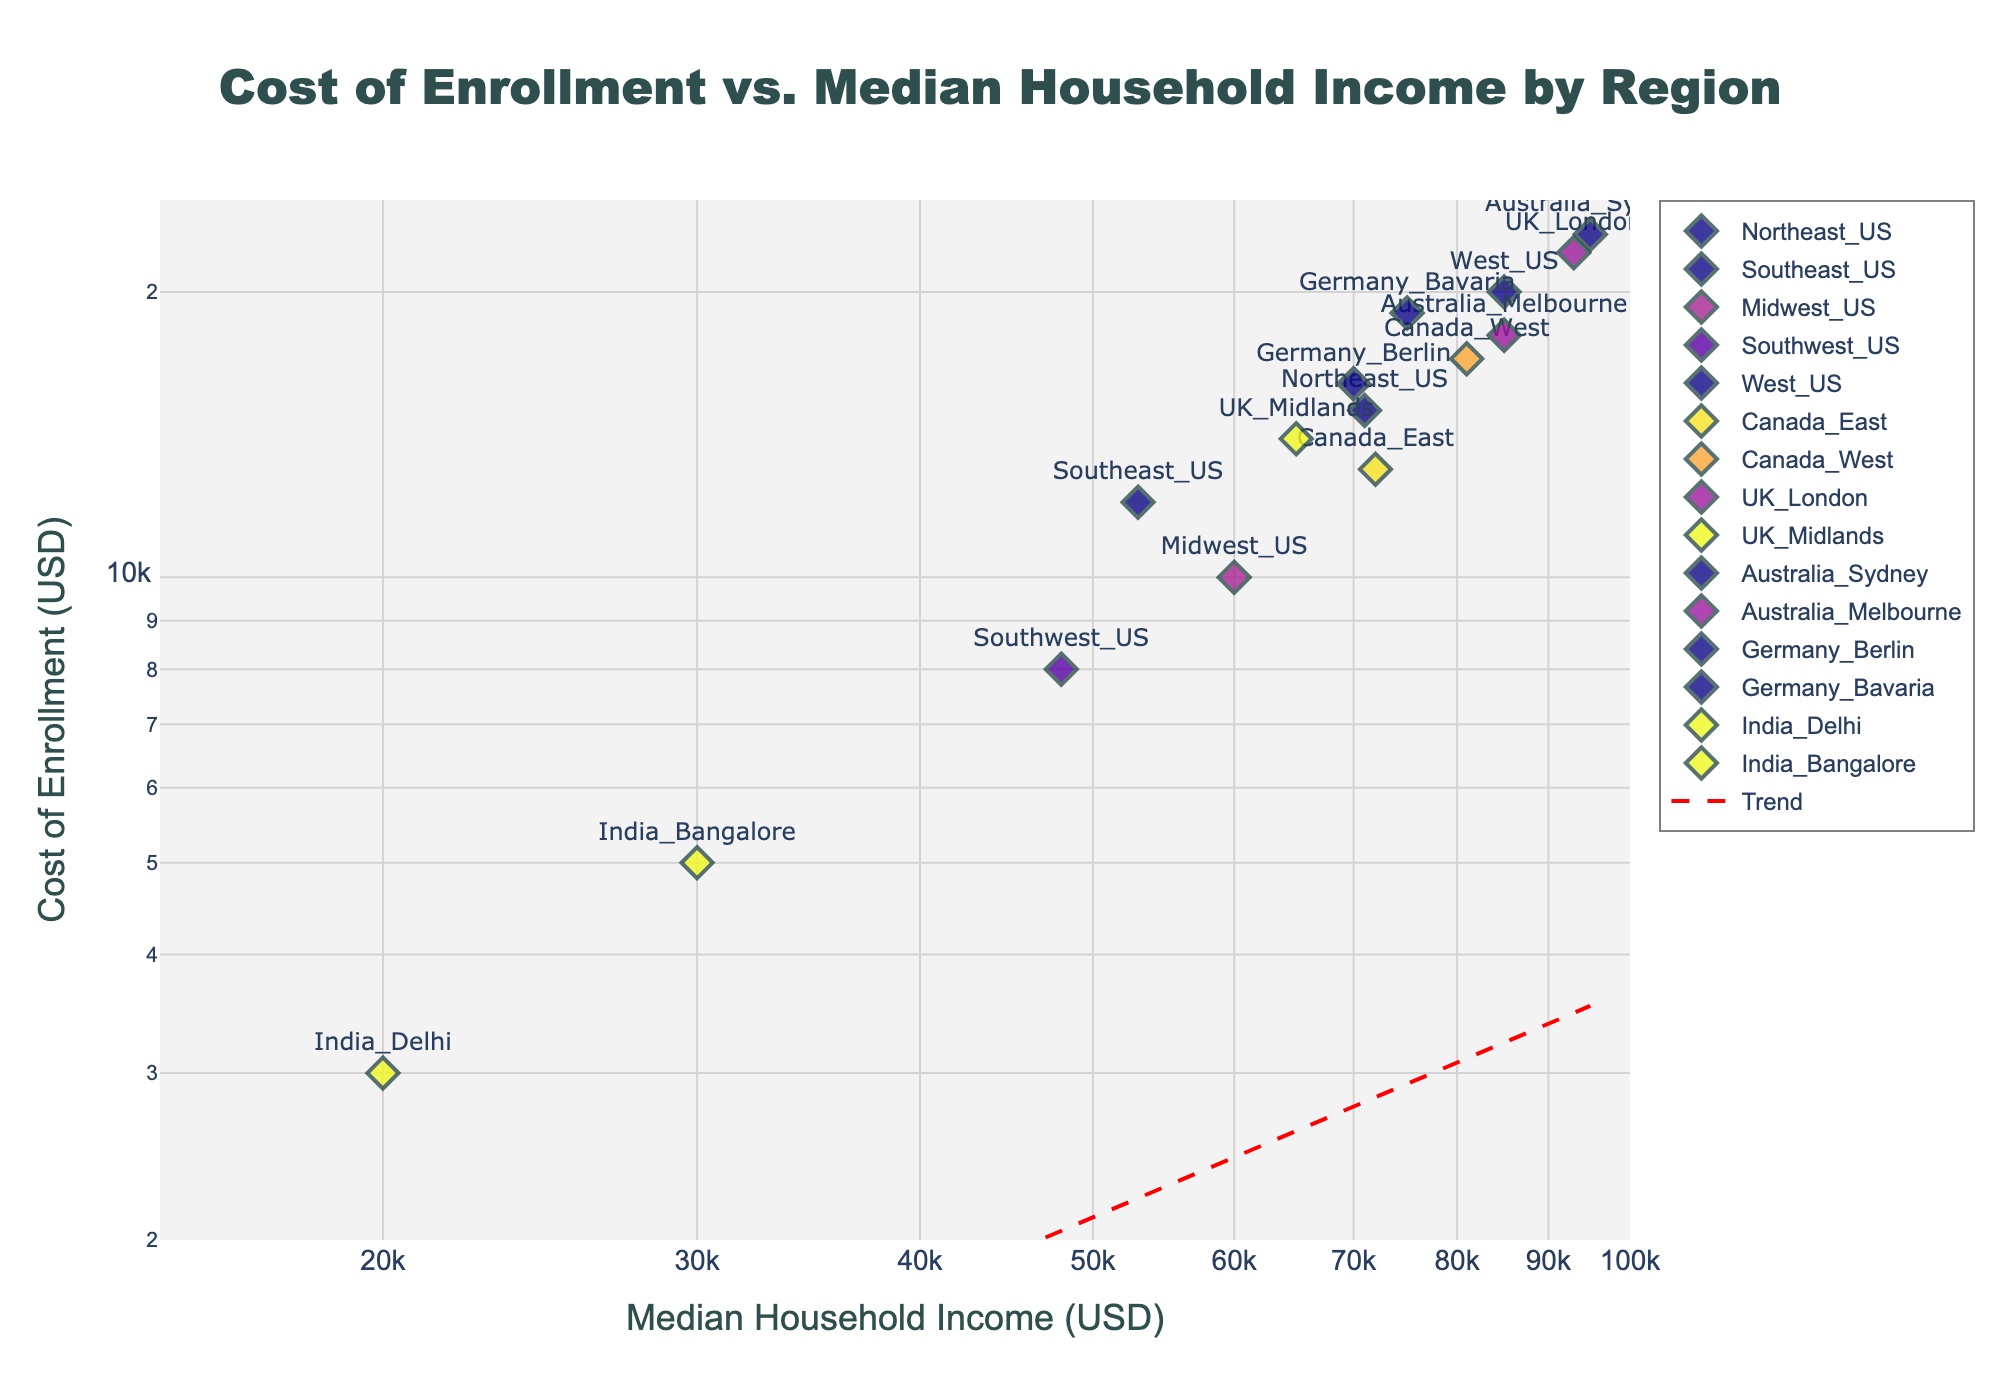What is the title of the figure? The title of the figure is located at the top and centered. It reads "Cost of Enrollment vs. Median Household Income by Region".
Answer: Cost of Enrollment vs. Median Household Income by Region What are the axes labeled? The x-axis is labeled "Median Household Income (USD)" and the y-axis is labeled "Cost of Enrollment (USD)". Both axis labels indicate a logarithmic scale.
Answer: Median Household Income (USD), Cost of Enrollment (USD) Which region has the highest cost of enrollment? The region with the highest cost of enrollment can be identified by looking at the highest point on the y-axis. This point, labeled “Australia_Sydney”, indicates a cost of enrollment of 23,000 USD.
Answer: Australia_Sydney Which region has the lowest median household income? The region with the lowest median household income is found at the leftmost point on the x-axis. The point is labeled "India_Delhi", indicating a median household income of 20,000 USD.
Answer: India_Delhi What is the approximate range of median household income values on the x-axis? The x-axis range can be observed between the lowest and highest points. It starts at around 20,000 USD (India_Delhi) and goes up to approximately 95,000 USD (Australia_Sydney).
Answer: 20,000 to 95,000 USD How many regions have a median household income of over 80,000 USD? By looking at the data points located above 80,000 USD on the x-axis, we count that there are four regions: West_US, Canada_West, UK_London, and Australia_Sydney.
Answer: Four regions Is there any visible trend between cost of enrollment and median household income? The trend line on the plot shows a positive relationship where, generally, as median household income increases, the cost of enrollment also tends to increase, indicated by the upward-sloping red dashed line.
Answer: Positive relationship In which region is the cost of enrollment closest to the median household income? By visually comparing the proximity of the points to a 1:1 line (if it existed), the point closest among all appears to be "Australia_Sydney" where cost (23,000 USD) is just below the highest income (95,000 USD), giving the most visually close proportion.
Answer: Australia_Sydney What is the difference in cost of enrollment between the most affordable and most expensive regions? The most affordable region is India_Delhi with enrollment costing 3,000 USD, and the most expensive is Australia_Sydney at 23,000 USD. The difference is calculated as 23,000 - 3,000 = 20,000 USD.
Answer: 20,000 USD Which region has a slightly higher cost of enrollment than Canada_West? The point for Canada_West is labeled and shows a cost of 17,000 USD. The next point above this is Germany_Bavaria with a cost of 19,000 USD.
Answer: Germany_Bavaria 